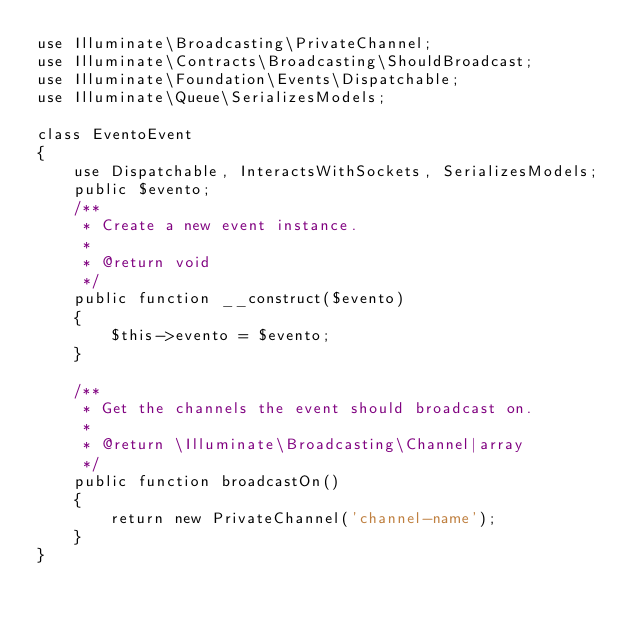Convert code to text. <code><loc_0><loc_0><loc_500><loc_500><_PHP_>use Illuminate\Broadcasting\PrivateChannel;
use Illuminate\Contracts\Broadcasting\ShouldBroadcast;
use Illuminate\Foundation\Events\Dispatchable;
use Illuminate\Queue\SerializesModels;

class EventoEvent
{
    use Dispatchable, InteractsWithSockets, SerializesModels;
    public $evento;
    /**
     * Create a new event instance.
     *
     * @return void
     */
    public function __construct($evento)
    {
        $this->evento = $evento;
    }

    /**
     * Get the channels the event should broadcast on.
     *
     * @return \Illuminate\Broadcasting\Channel|array
     */
    public function broadcastOn()
    {
        return new PrivateChannel('channel-name');
    }
}
</code> 